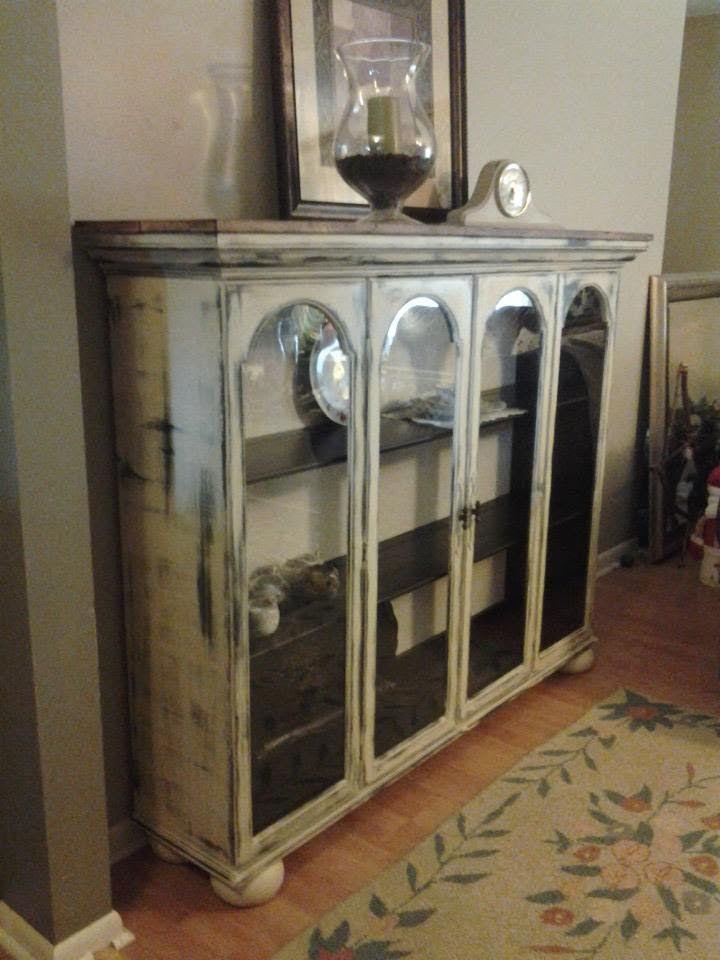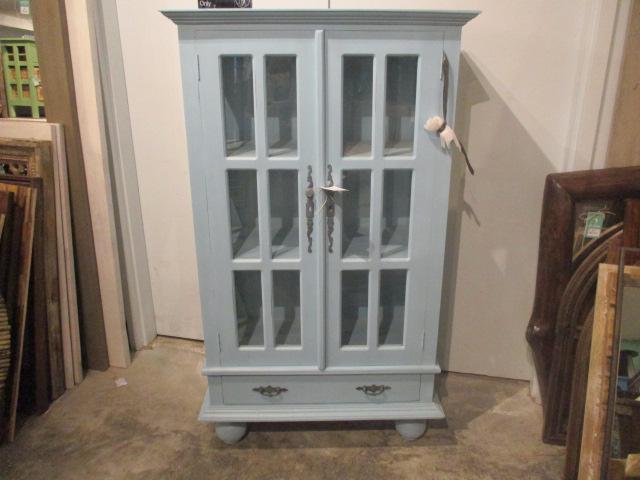The first image is the image on the left, the second image is the image on the right. Assess this claim about the two images: "An image shows a flat-topped grayish cabinet with something round on the wall behind it and nothing inside it.". Correct or not? Answer yes or no. No. The first image is the image on the left, the second image is the image on the right. Assess this claim about the two images: "A low wooden cabinet in one image is made from the top of a larger hutch, sits on low rounded feet, and has four doors with long arched glass inserts.". Correct or not? Answer yes or no. Yes. The first image is the image on the left, the second image is the image on the right. Examine the images to the left and right. Is the description "One of the images includes warm-colored flowers." accurate? Answer yes or no. No. The first image is the image on the left, the second image is the image on the right. Given the left and right images, does the statement "The cabinet on the left is visibly full of dishes, and the one on the right is not." hold true? Answer yes or no. No. 